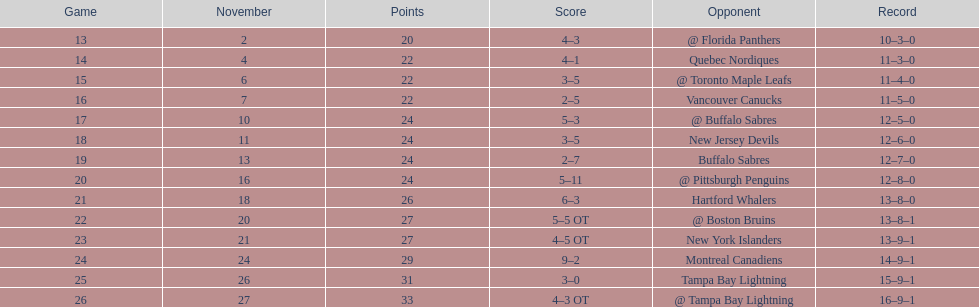Who had the most assists on the 1993-1994 flyers? Mark Recchi. 